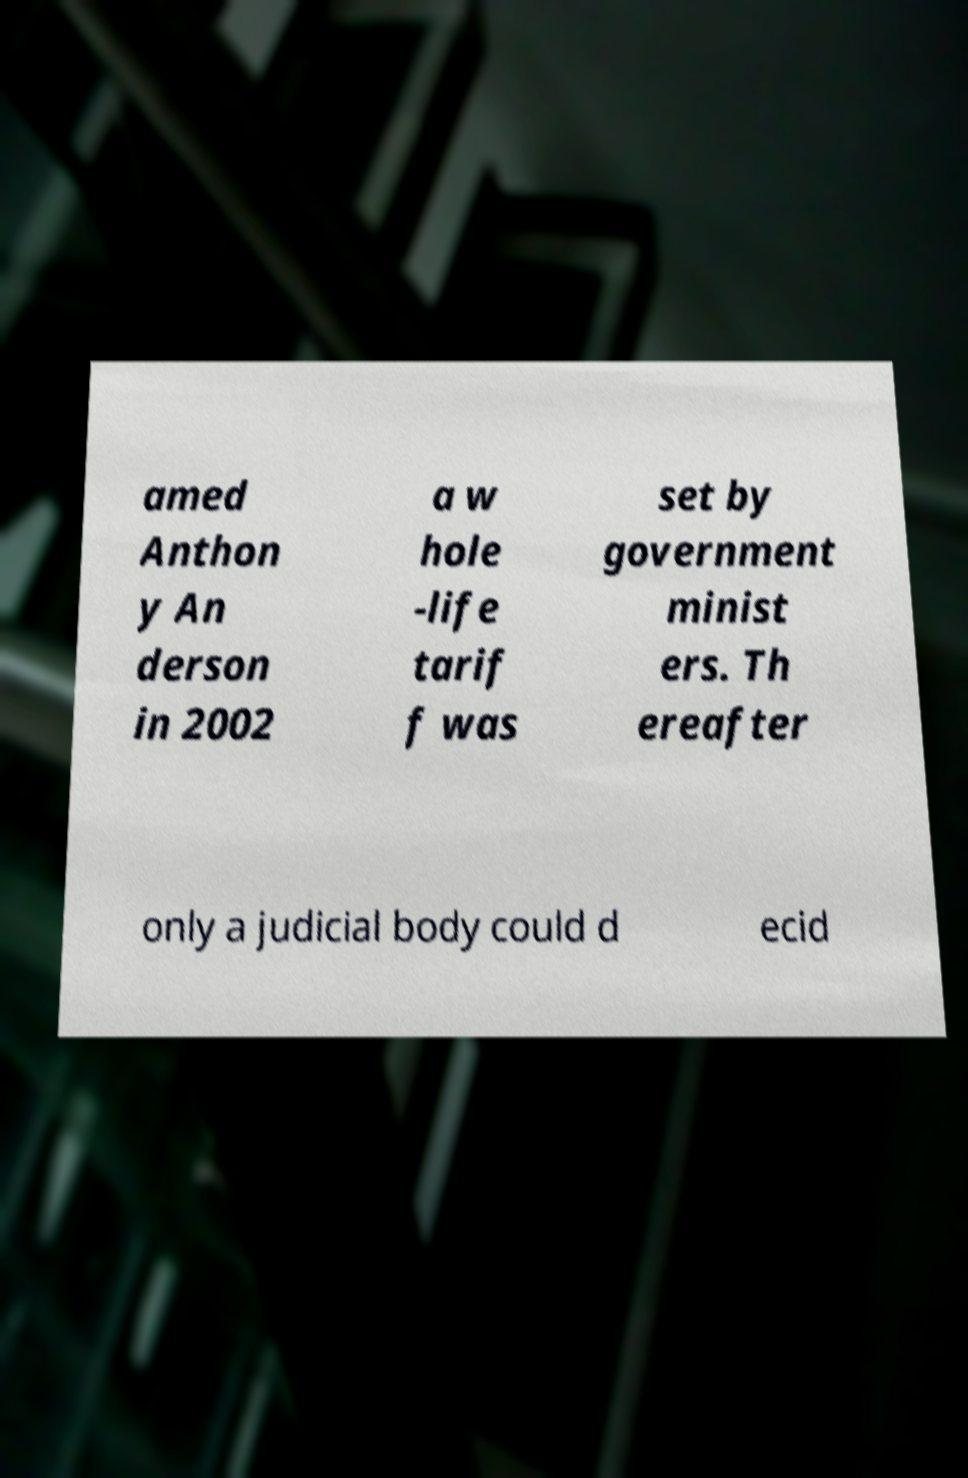For documentation purposes, I need the text within this image transcribed. Could you provide that? amed Anthon y An derson in 2002 a w hole -life tarif f was set by government minist ers. Th ereafter only a judicial body could d ecid 